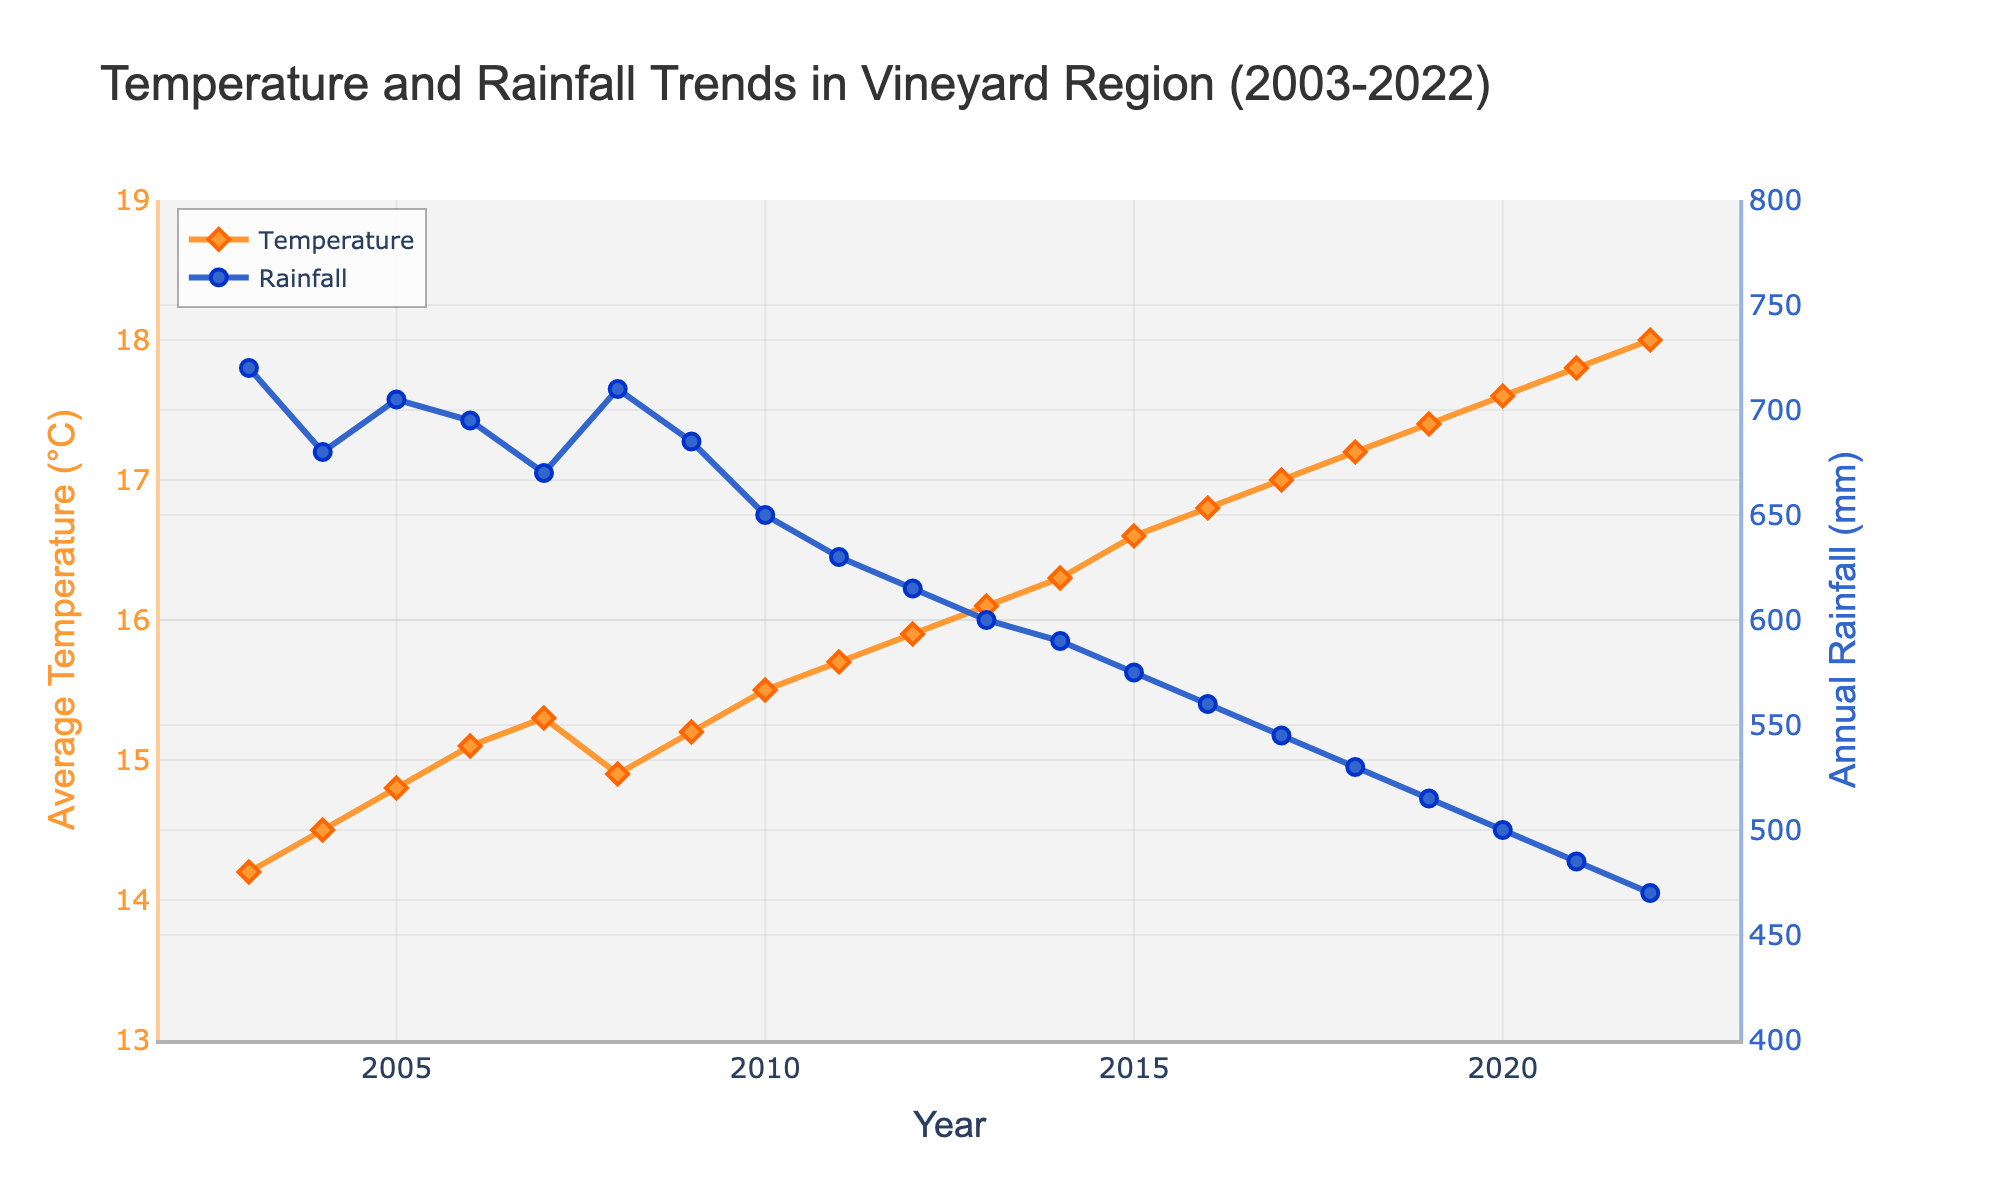What is the trend in average temperature over the 20 years in the vineyard region? The figure displays a line that shows a general increase in average temperature over the years. Starting at 14.2°C in 2003, it steadily rises to 18.0°C by 2022.
Answer: Increasing trend Comparing 2003 and 2022, how much has the annual rainfall decreased? The annual rainfall in 2003 was 720 mm, and in 2022 it was 470 mm. The difference is 720 mm - 470 mm = 250 mm.
Answer: 250 mm Which year experienced the highest average temperature according to the figure? In the figure, 2022 shows the highest average temperature, which is 18.0°C.
Answer: 2022 Between 2010 and 2020, which year had the lowest annual rainfall? From 2010 to 2020, the year with the lowest annual rainfall is 2020, with 500 mm.
Answer: 2020 Is there a visible correlation between the average temperature and annual rainfall in the vineyard region over the 20 years? The figure shows that as the average temperature increases, the annual rainfall tends to decrease, indicating a possible inverse correlation.
Answer: Inverse correlation What is the average rate of increase in temperature per year over the 20 years? The temperature increases from 14.2°C in 2003 to 18.0°C in 2022. The total increase is 18.0°C - 14.2°C = 3.8°C. Over 20 years, the average rate of increase per year is 3.8°C / 20 years = 0.19°C/year.
Answer: 0.19°C/year Which year had almost the same average temperature and annual rainfall (closest values)? In 2008, the average temperature was 14.9°C, and the annual rainfall was 710 mm, resulting in the closest values among all years, although they measure different things.
Answer: 2008 How does the visual presentation differentiate between temperature and rainfall measurements? The temperature is depicted with an orange line and diamond-shaped markers, while the rainfall is shown with a blue line and circular markers, differentiating the two parameters visually.
Answer: Color and shape differentiation How many times does the annual rainfall value decrease consecutively over the 20 years? Examining the figure, the annual rainfall decreases consecutively every year from 2010 to 2022, totaling 12 times.
Answer: 12 times 